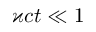<formula> <loc_0><loc_0><loc_500><loc_500>\varkappa c t \ll 1</formula> 